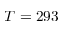Convert formula to latex. <formula><loc_0><loc_0><loc_500><loc_500>T = 2 9 3</formula> 